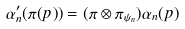<formula> <loc_0><loc_0><loc_500><loc_500>\alpha _ { n } ^ { \prime } ( \pi ( p ) ) = ( \pi \otimes \pi _ { \psi _ { n } } ) \alpha _ { n } ( p )</formula> 